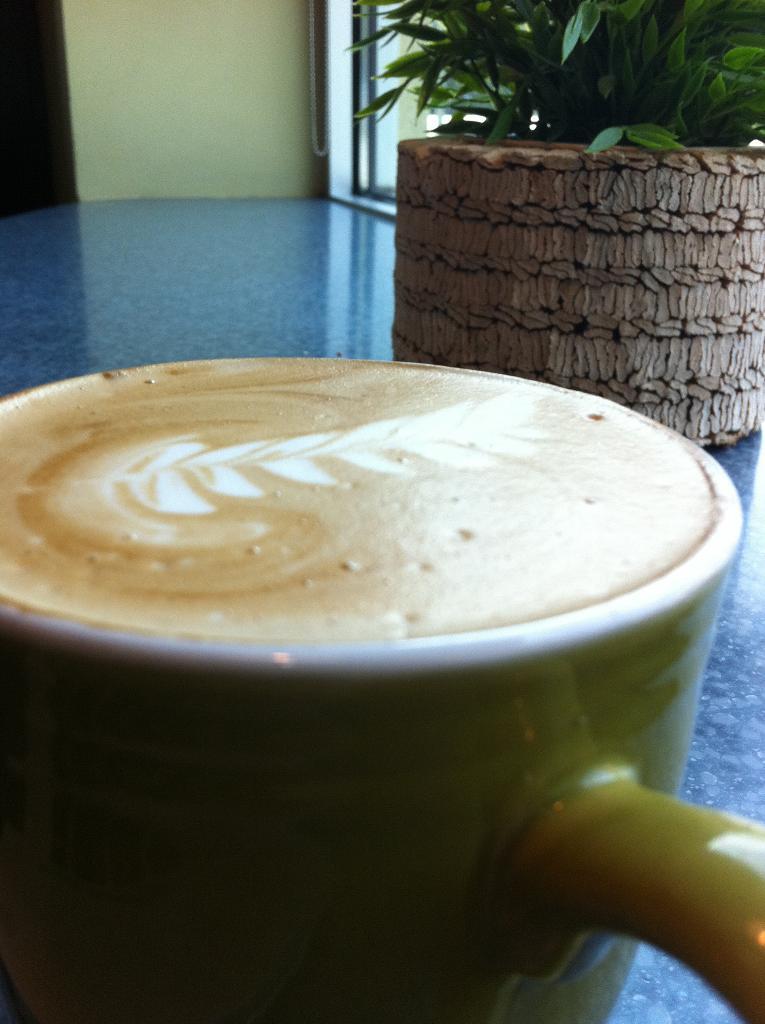Describe this image in one or two sentences. In this image we can see a coffee mug and a houseplant placed on the table. 